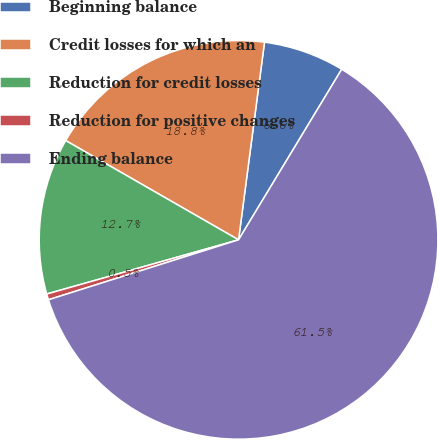Convert chart. <chart><loc_0><loc_0><loc_500><loc_500><pie_chart><fcel>Beginning balance<fcel>Credit losses for which an<fcel>Reduction for credit losses<fcel>Reduction for positive changes<fcel>Ending balance<nl><fcel>6.58%<fcel>18.78%<fcel>12.68%<fcel>0.48%<fcel>61.48%<nl></chart> 